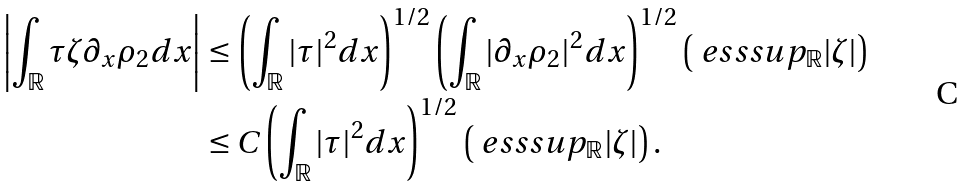<formula> <loc_0><loc_0><loc_500><loc_500>\left | \int _ { \mathbb { R } } \tau \zeta \partial _ { x } \rho _ { 2 } d x \right | & \leq \left ( \int _ { \mathbb { R } } | \tau | ^ { 2 } d x \right ) ^ { 1 / 2 } \left ( \int _ { \mathbb { R } } | \partial _ { x } \rho _ { 2 } | ^ { 2 } d x \right ) ^ { 1 / 2 } \left ( \ e s s s u p _ { \mathbb { R } } | \zeta | \right ) \\ & \leq C \left ( \int _ { \mathbb { R } } | \tau | ^ { 2 } d x \right ) ^ { 1 / 2 } \left ( \ e s s s u p _ { \mathbb { R } } | \zeta | \right ) .</formula> 